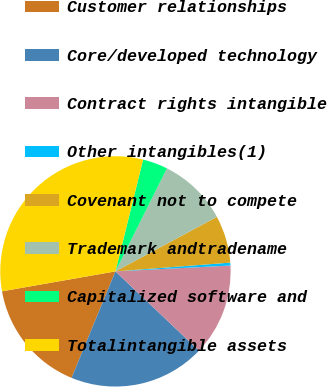Convert chart. <chart><loc_0><loc_0><loc_500><loc_500><pie_chart><fcel>Customer relationships<fcel>Core/developed technology<fcel>Contract rights intangible<fcel>Other intangibles(1)<fcel>Covenant not to compete<fcel>Trademark andtradename<fcel>Capitalized software and<fcel>Totalintangible assets<nl><fcel>16.01%<fcel>19.14%<fcel>12.89%<fcel>0.4%<fcel>6.64%<fcel>9.77%<fcel>3.52%<fcel>31.63%<nl></chart> 